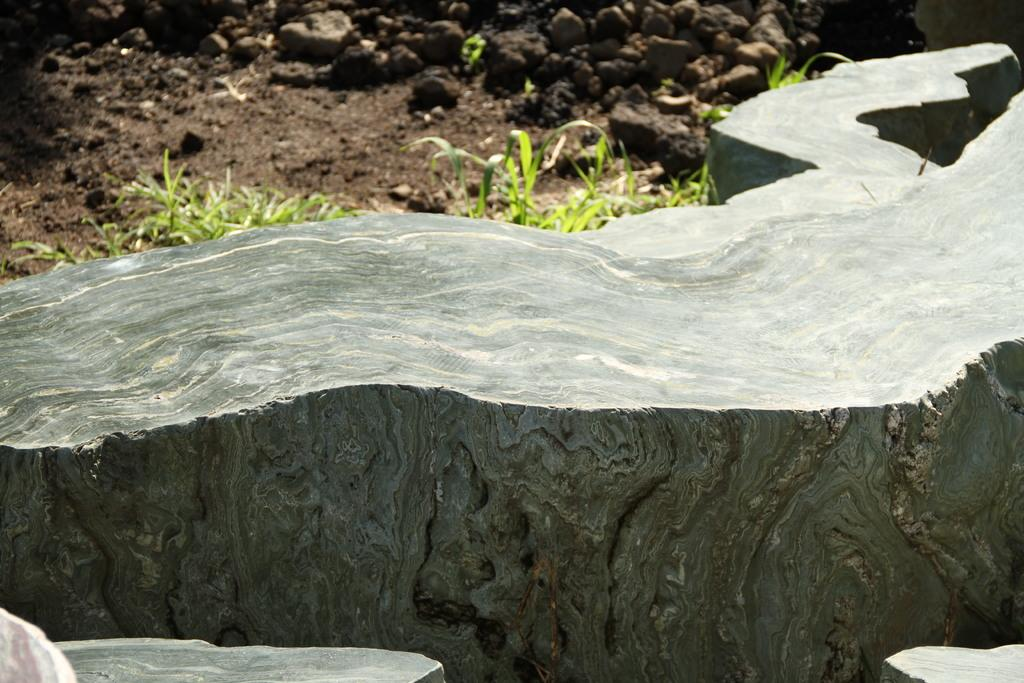Where was the image taken? The image was taken outdoors. What can be seen at the bottom of the image? There are rocks at the bottom of the image. What type of ground is visible at the top of the image? There is a ground with grass at the top of the image. What type of liquid is being attacked by the rocks in the image? There is no liquid or attack present in the image; it features rocks and grassy ground. 